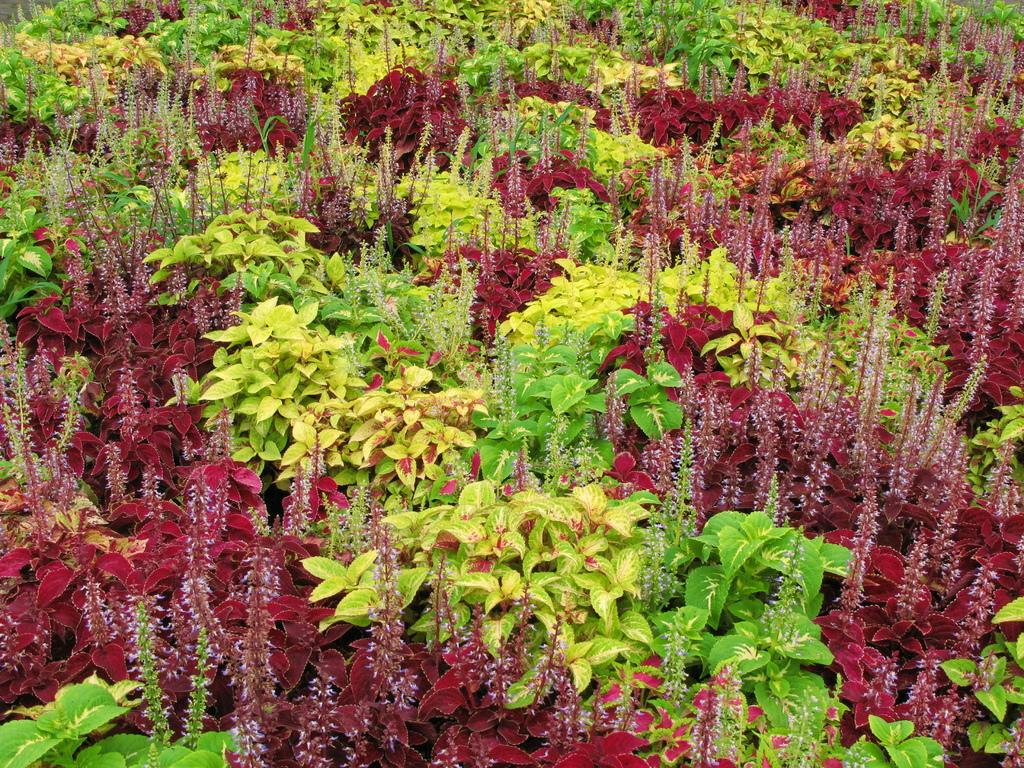What type of living organisms can be seen in the image? Plants can be seen in the image. What colors are present on the leaves of the plants? The leaves of the plants have green, yellow, and maroon colors. What type of debt is being discussed in the image? There is no mention of debt in the image; it features plants with leaves of various colors. 